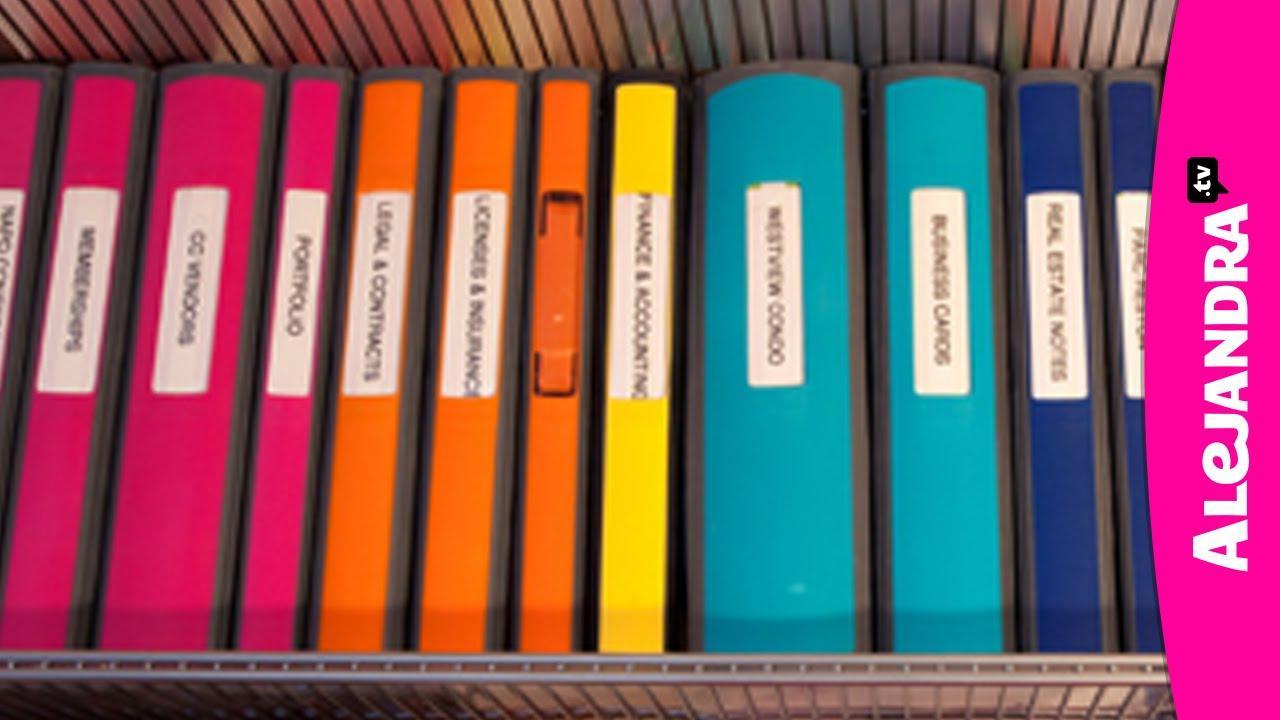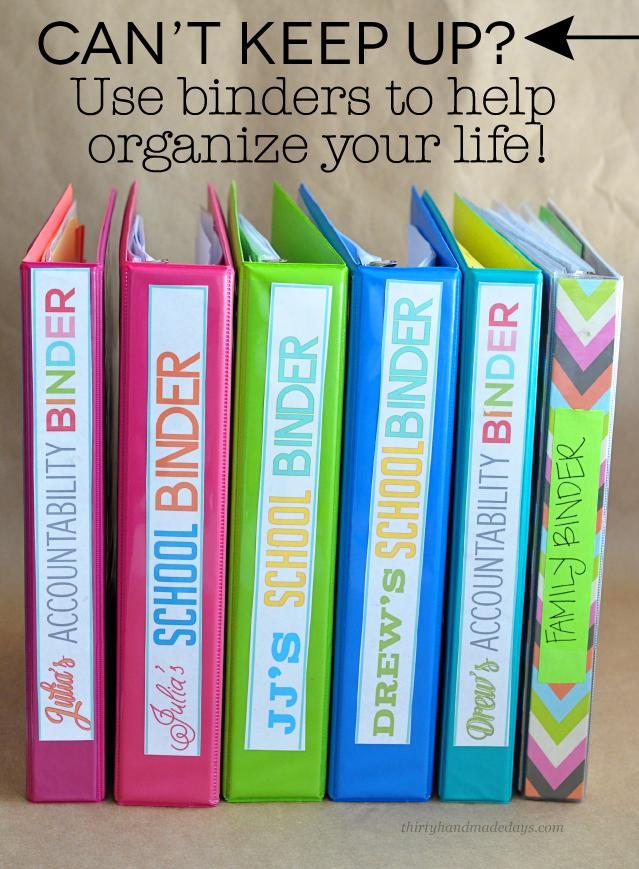The first image is the image on the left, the second image is the image on the right. Assess this claim about the two images: "In one image, a row of notebooks in various colors stands on end, while a second image shows a single notebook open to show three rings and its contents.". Correct or not? Answer yes or no. No. The first image is the image on the left, the second image is the image on the right. Examine the images to the left and right. Is the description "An image shows one opened binder filled with supplies, including a pen." accurate? Answer yes or no. No. 